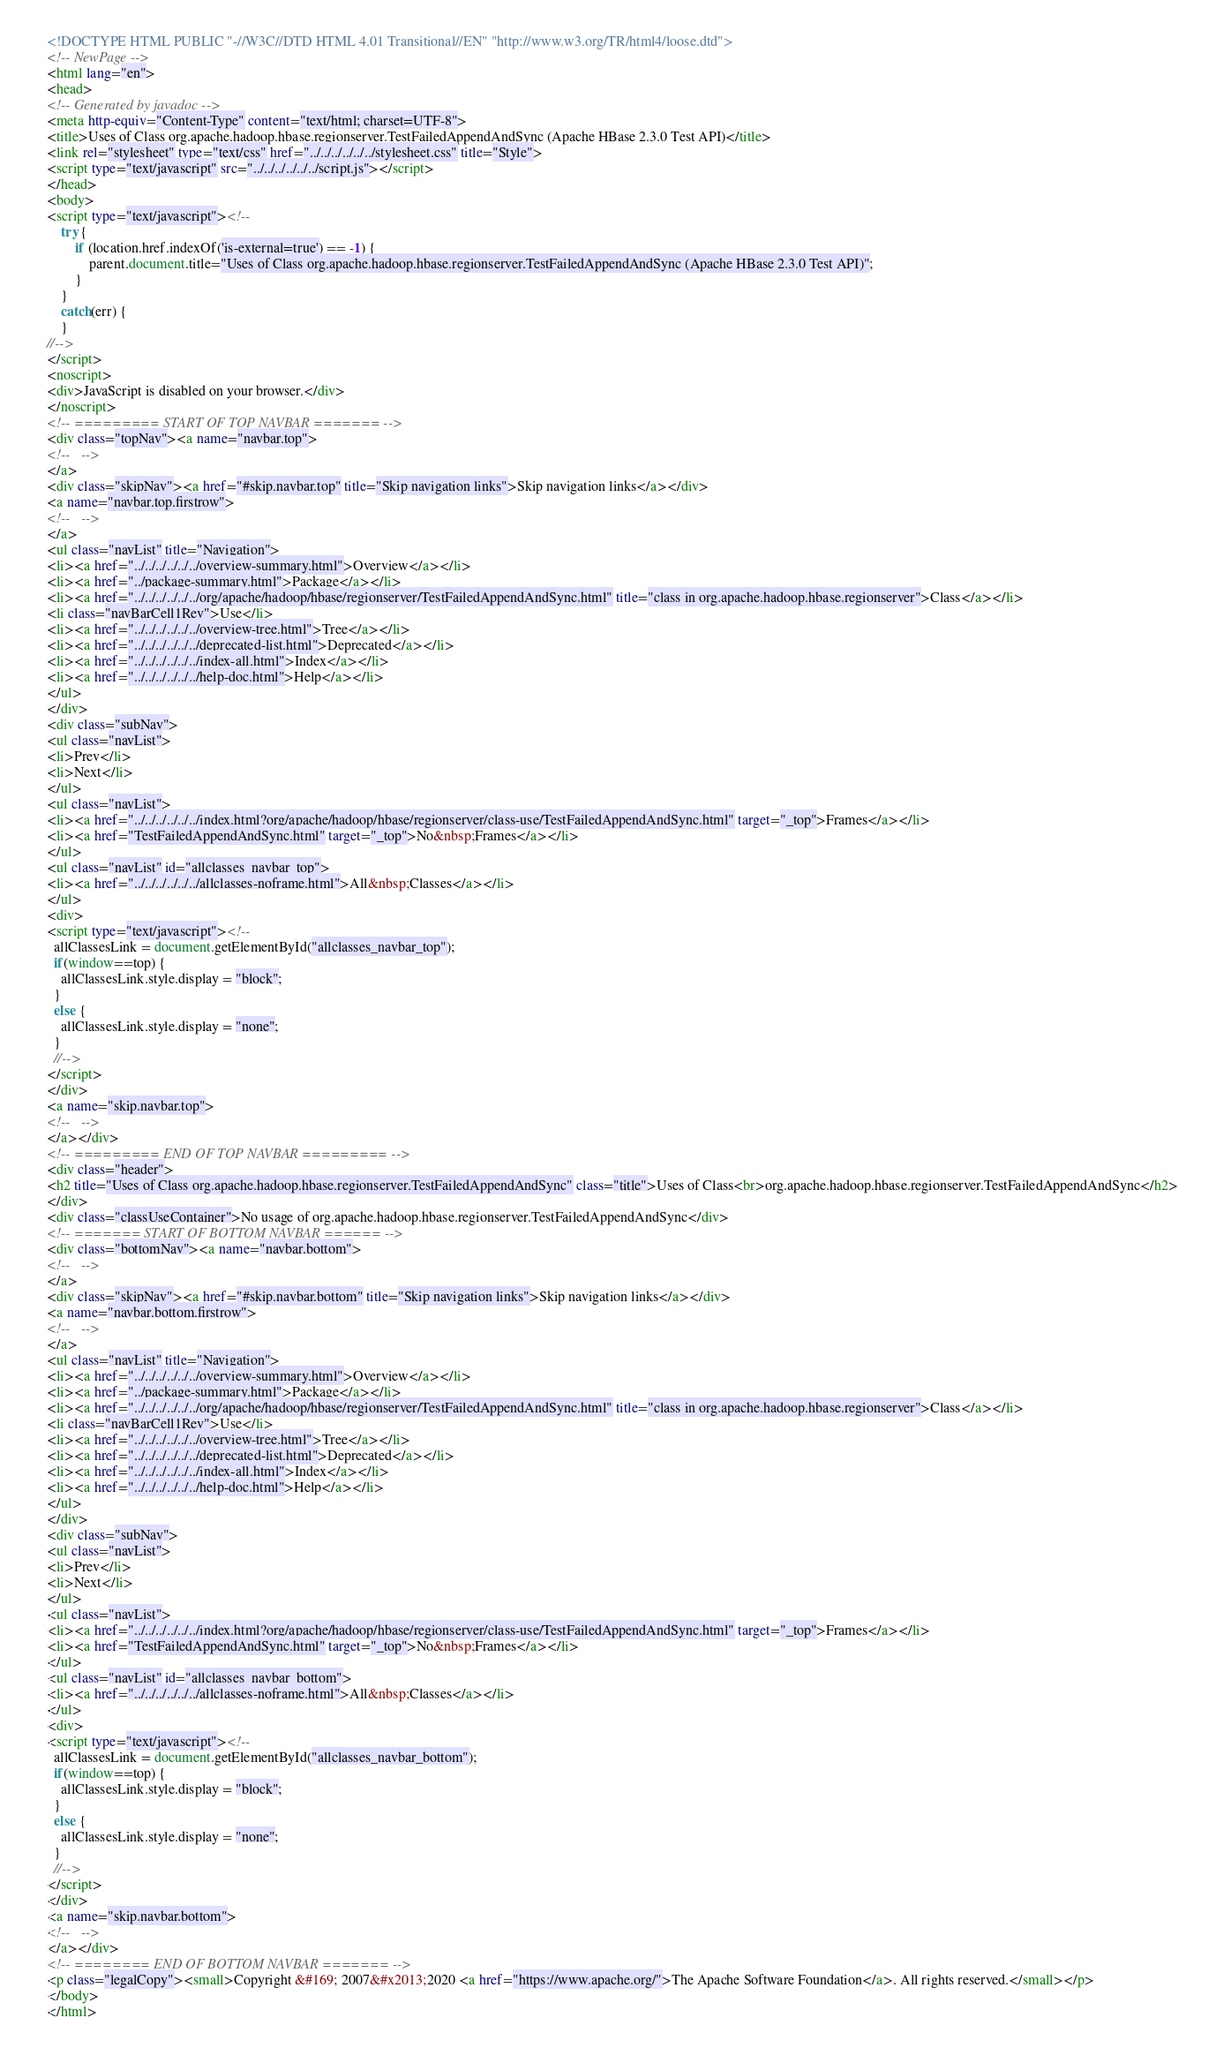Convert code to text. <code><loc_0><loc_0><loc_500><loc_500><_HTML_><!DOCTYPE HTML PUBLIC "-//W3C//DTD HTML 4.01 Transitional//EN" "http://www.w3.org/TR/html4/loose.dtd">
<!-- NewPage -->
<html lang="en">
<head>
<!-- Generated by javadoc -->
<meta http-equiv="Content-Type" content="text/html; charset=UTF-8">
<title>Uses of Class org.apache.hadoop.hbase.regionserver.TestFailedAppendAndSync (Apache HBase 2.3.0 Test API)</title>
<link rel="stylesheet" type="text/css" href="../../../../../../stylesheet.css" title="Style">
<script type="text/javascript" src="../../../../../../script.js"></script>
</head>
<body>
<script type="text/javascript"><!--
    try {
        if (location.href.indexOf('is-external=true') == -1) {
            parent.document.title="Uses of Class org.apache.hadoop.hbase.regionserver.TestFailedAppendAndSync (Apache HBase 2.3.0 Test API)";
        }
    }
    catch(err) {
    }
//-->
</script>
<noscript>
<div>JavaScript is disabled on your browser.</div>
</noscript>
<!-- ========= START OF TOP NAVBAR ======= -->
<div class="topNav"><a name="navbar.top">
<!--   -->
</a>
<div class="skipNav"><a href="#skip.navbar.top" title="Skip navigation links">Skip navigation links</a></div>
<a name="navbar.top.firstrow">
<!--   -->
</a>
<ul class="navList" title="Navigation">
<li><a href="../../../../../../overview-summary.html">Overview</a></li>
<li><a href="../package-summary.html">Package</a></li>
<li><a href="../../../../../../org/apache/hadoop/hbase/regionserver/TestFailedAppendAndSync.html" title="class in org.apache.hadoop.hbase.regionserver">Class</a></li>
<li class="navBarCell1Rev">Use</li>
<li><a href="../../../../../../overview-tree.html">Tree</a></li>
<li><a href="../../../../../../deprecated-list.html">Deprecated</a></li>
<li><a href="../../../../../../index-all.html">Index</a></li>
<li><a href="../../../../../../help-doc.html">Help</a></li>
</ul>
</div>
<div class="subNav">
<ul class="navList">
<li>Prev</li>
<li>Next</li>
</ul>
<ul class="navList">
<li><a href="../../../../../../index.html?org/apache/hadoop/hbase/regionserver/class-use/TestFailedAppendAndSync.html" target="_top">Frames</a></li>
<li><a href="TestFailedAppendAndSync.html" target="_top">No&nbsp;Frames</a></li>
</ul>
<ul class="navList" id="allclasses_navbar_top">
<li><a href="../../../../../../allclasses-noframe.html">All&nbsp;Classes</a></li>
</ul>
<div>
<script type="text/javascript"><!--
  allClassesLink = document.getElementById("allclasses_navbar_top");
  if(window==top) {
    allClassesLink.style.display = "block";
  }
  else {
    allClassesLink.style.display = "none";
  }
  //-->
</script>
</div>
<a name="skip.navbar.top">
<!--   -->
</a></div>
<!-- ========= END OF TOP NAVBAR ========= -->
<div class="header">
<h2 title="Uses of Class org.apache.hadoop.hbase.regionserver.TestFailedAppendAndSync" class="title">Uses of Class<br>org.apache.hadoop.hbase.regionserver.TestFailedAppendAndSync</h2>
</div>
<div class="classUseContainer">No usage of org.apache.hadoop.hbase.regionserver.TestFailedAppendAndSync</div>
<!-- ======= START OF BOTTOM NAVBAR ====== -->
<div class="bottomNav"><a name="navbar.bottom">
<!--   -->
</a>
<div class="skipNav"><a href="#skip.navbar.bottom" title="Skip navigation links">Skip navigation links</a></div>
<a name="navbar.bottom.firstrow">
<!--   -->
</a>
<ul class="navList" title="Navigation">
<li><a href="../../../../../../overview-summary.html">Overview</a></li>
<li><a href="../package-summary.html">Package</a></li>
<li><a href="../../../../../../org/apache/hadoop/hbase/regionserver/TestFailedAppendAndSync.html" title="class in org.apache.hadoop.hbase.regionserver">Class</a></li>
<li class="navBarCell1Rev">Use</li>
<li><a href="../../../../../../overview-tree.html">Tree</a></li>
<li><a href="../../../../../../deprecated-list.html">Deprecated</a></li>
<li><a href="../../../../../../index-all.html">Index</a></li>
<li><a href="../../../../../../help-doc.html">Help</a></li>
</ul>
</div>
<div class="subNav">
<ul class="navList">
<li>Prev</li>
<li>Next</li>
</ul>
<ul class="navList">
<li><a href="../../../../../../index.html?org/apache/hadoop/hbase/regionserver/class-use/TestFailedAppendAndSync.html" target="_top">Frames</a></li>
<li><a href="TestFailedAppendAndSync.html" target="_top">No&nbsp;Frames</a></li>
</ul>
<ul class="navList" id="allclasses_navbar_bottom">
<li><a href="../../../../../../allclasses-noframe.html">All&nbsp;Classes</a></li>
</ul>
<div>
<script type="text/javascript"><!--
  allClassesLink = document.getElementById("allclasses_navbar_bottom");
  if(window==top) {
    allClassesLink.style.display = "block";
  }
  else {
    allClassesLink.style.display = "none";
  }
  //-->
</script>
</div>
<a name="skip.navbar.bottom">
<!--   -->
</a></div>
<!-- ======== END OF BOTTOM NAVBAR ======= -->
<p class="legalCopy"><small>Copyright &#169; 2007&#x2013;2020 <a href="https://www.apache.org/">The Apache Software Foundation</a>. All rights reserved.</small></p>
</body>
</html>
</code> 